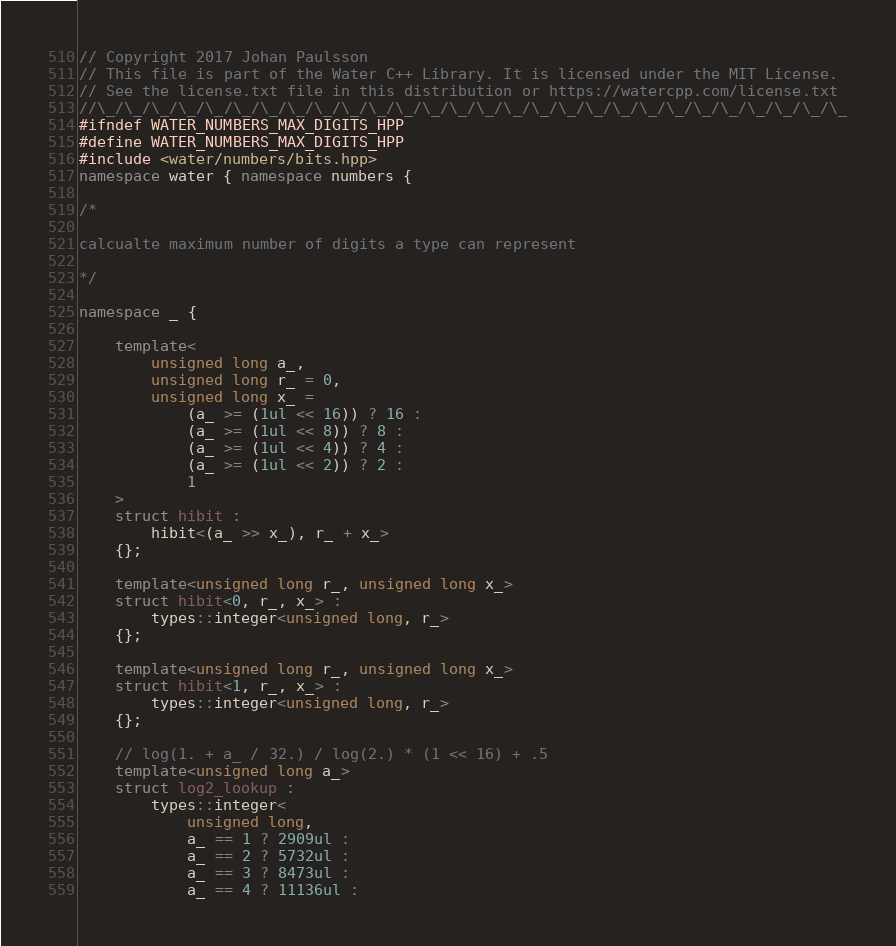Convert code to text. <code><loc_0><loc_0><loc_500><loc_500><_C++_>// Copyright 2017 Johan Paulsson
// This file is part of the Water C++ Library. It is licensed under the MIT License.
// See the license.txt file in this distribution or https://watercpp.com/license.txt
//\_/\_/\_/\_/\_/\_/\_/\_/\_/\_/\_/\_/\_/\_/\_/\_/\_/\_/\_/\_/\_/\_/\_/\_/\_/\_/\_/\_
#ifndef WATER_NUMBERS_MAX_DIGITS_HPP
#define WATER_NUMBERS_MAX_DIGITS_HPP
#include <water/numbers/bits.hpp>
namespace water { namespace numbers {

/*

calcualte maximum number of digits a type can represent

*/

namespace _ {

    template<
        unsigned long a_,
        unsigned long r_ = 0,
        unsigned long x_ =
            (a_ >= (1ul << 16)) ? 16 :
            (a_ >= (1ul << 8)) ? 8 :
            (a_ >= (1ul << 4)) ? 4 :
            (a_ >= (1ul << 2)) ? 2 :
            1
    >
    struct hibit :
        hibit<(a_ >> x_), r_ + x_>
    {};
    
    template<unsigned long r_, unsigned long x_>
    struct hibit<0, r_, x_> :
        types::integer<unsigned long, r_>
    {};
    
    template<unsigned long r_, unsigned long x_>
    struct hibit<1, r_, x_> :
        types::integer<unsigned long, r_>
    {};
    
    // log(1. + a_ / 32.) / log(2.) * (1 << 16) + .5
    template<unsigned long a_>
    struct log2_lookup :
        types::integer<
            unsigned long,
            a_ == 1 ? 2909ul :
            a_ == 2 ? 5732ul :
            a_ == 3 ? 8473ul :
            a_ == 4 ? 11136ul :</code> 